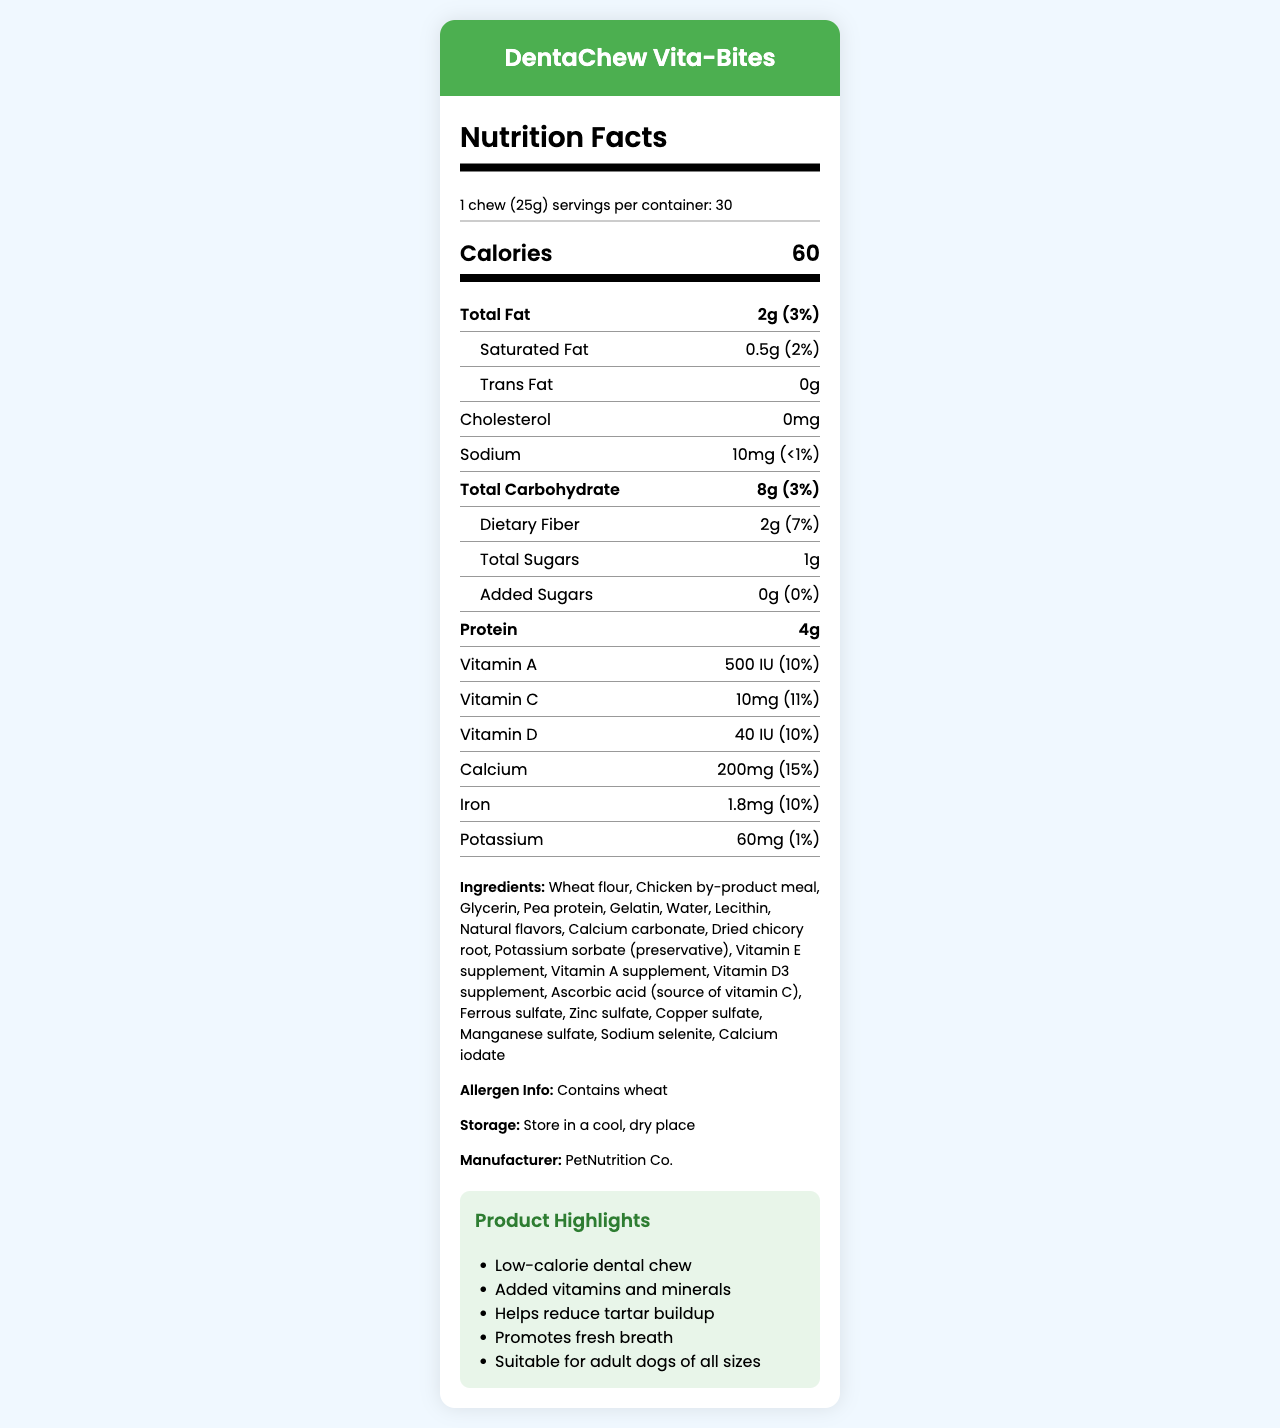who is the manufacturer of DentaChew Vita-Bites? The manufacturer information is provided under the "Ingredients" section.
Answer: PetNutrition Co. how many calories are in one chew of DentaChew Vita-Bites? The calorie information is prominently displayed in the "Calories" section in the nutrition facts.
Answer: 60 calories how much dietary fiber is in one serving? The amount of dietary fiber is listed under the "Dietary Fiber" sub-nutrient section.
Answer: 2g does DentaChew Vita-Bites contain any added sugars? The "Added Sugars" section shows that there are 0g of added sugars with a daily value of 0%.
Answer: No what vitamins are included in DentaChew Vita-Bites? The vitamins are listed in the "Vitamin A," "Vitamin C," and "Vitamin D" sections of the nutrition facts.
Answer: Vitamin A, Vitamin C, Vitamin D how many servings are in one container of DentaChew Vita-Bites? This information is provided at the top under the "serving size" and "servings per container" section.
Answer: 30 servings what is the batch number of this product? The batch number is provided at the bottom of the document under product details.
Answer: DC2023051 which of the following is NOT an ingredient in DentaChew Vita-Bites? A. Wheat flour B. Chicken by-product meal C. Corn syrup Corn syrup is not mentioned in the list of ingredients, while wheat flour and chicken by-product meal are.
Answer: C. Corn syrup what is the total fat content in one chew? A. 1g B. 2g C. 0.5g D. 4g The nutrition facts specify that the total fat content is 2g per serving.
Answer: B. 2g does the product help reduce tartar buildup? (Yes/No) This is listed under the "Product Highlights" section.
Answer: Yes provide a brief summary of DentaChew Vita-Bites' main features. The summary encapsulates the key features, nutritional information, and purpose of the product as detailed in the document.
Answer: DentaChew Vita-Bites is a low-calorie, vitamin-enriched dental chew for dogs, designed to help reduce tartar buildup and promote fresh breath. It is suitable for adult dogs of all sizes, contains 60 calories per chew, is made with various supplements like vitamins A, C, and D, and is manufactured by PetNutrition Co. what is the recommended feeding instruction? The recommended feeding instruction is explicitly mentioned in the document's feeding instructions section.
Answer: Feed one chew per day as a treat or dental supplement. Not intended as a meal replacement. Always provide fresh water. what is the daily value percentage of calcium in DentaChew Vita-Bites? The daily value percentage for calcium is listed as 15% in the nutritional information.
Answer: 15% is DentaChew Vita-Bites veterinarian endorsed? The document indicates that the product is veterinarian endorsed.
Answer: Yes which country is DentaChew Vita-Bites made in? The product is made in the USA as stated under the product details.
Answer: USA how does DentaChew Vita-Bites promote dental health for dogs? This information is highlighted under the "Product Highlights" section.
Answer: Helps reduce tartar buildup and promotes fresh breath what is the source of vitamin C in DentaChew Vita-Bites? The ingredient list includes ascorbic acid as the source of vitamin C.
Answer: Ascorbic acid how much cholesterol is in one serving? The nutritional information indicates that there is 0mg of cholesterol per serving.
Answer: 0mg what is the storage recommendation for DentaChew Vita-Bites? The storage recommendation is clearly mentioned under the "Storage" section.
Answer: Store in a cool, dry place are there any fish-based ingredients in DentaChew Vita-Bites? The ingredient list does not mention any fish-based ingredients, but it does not provide enough detail to confirm that there are no such ingredients.
Answer: Not enough information 